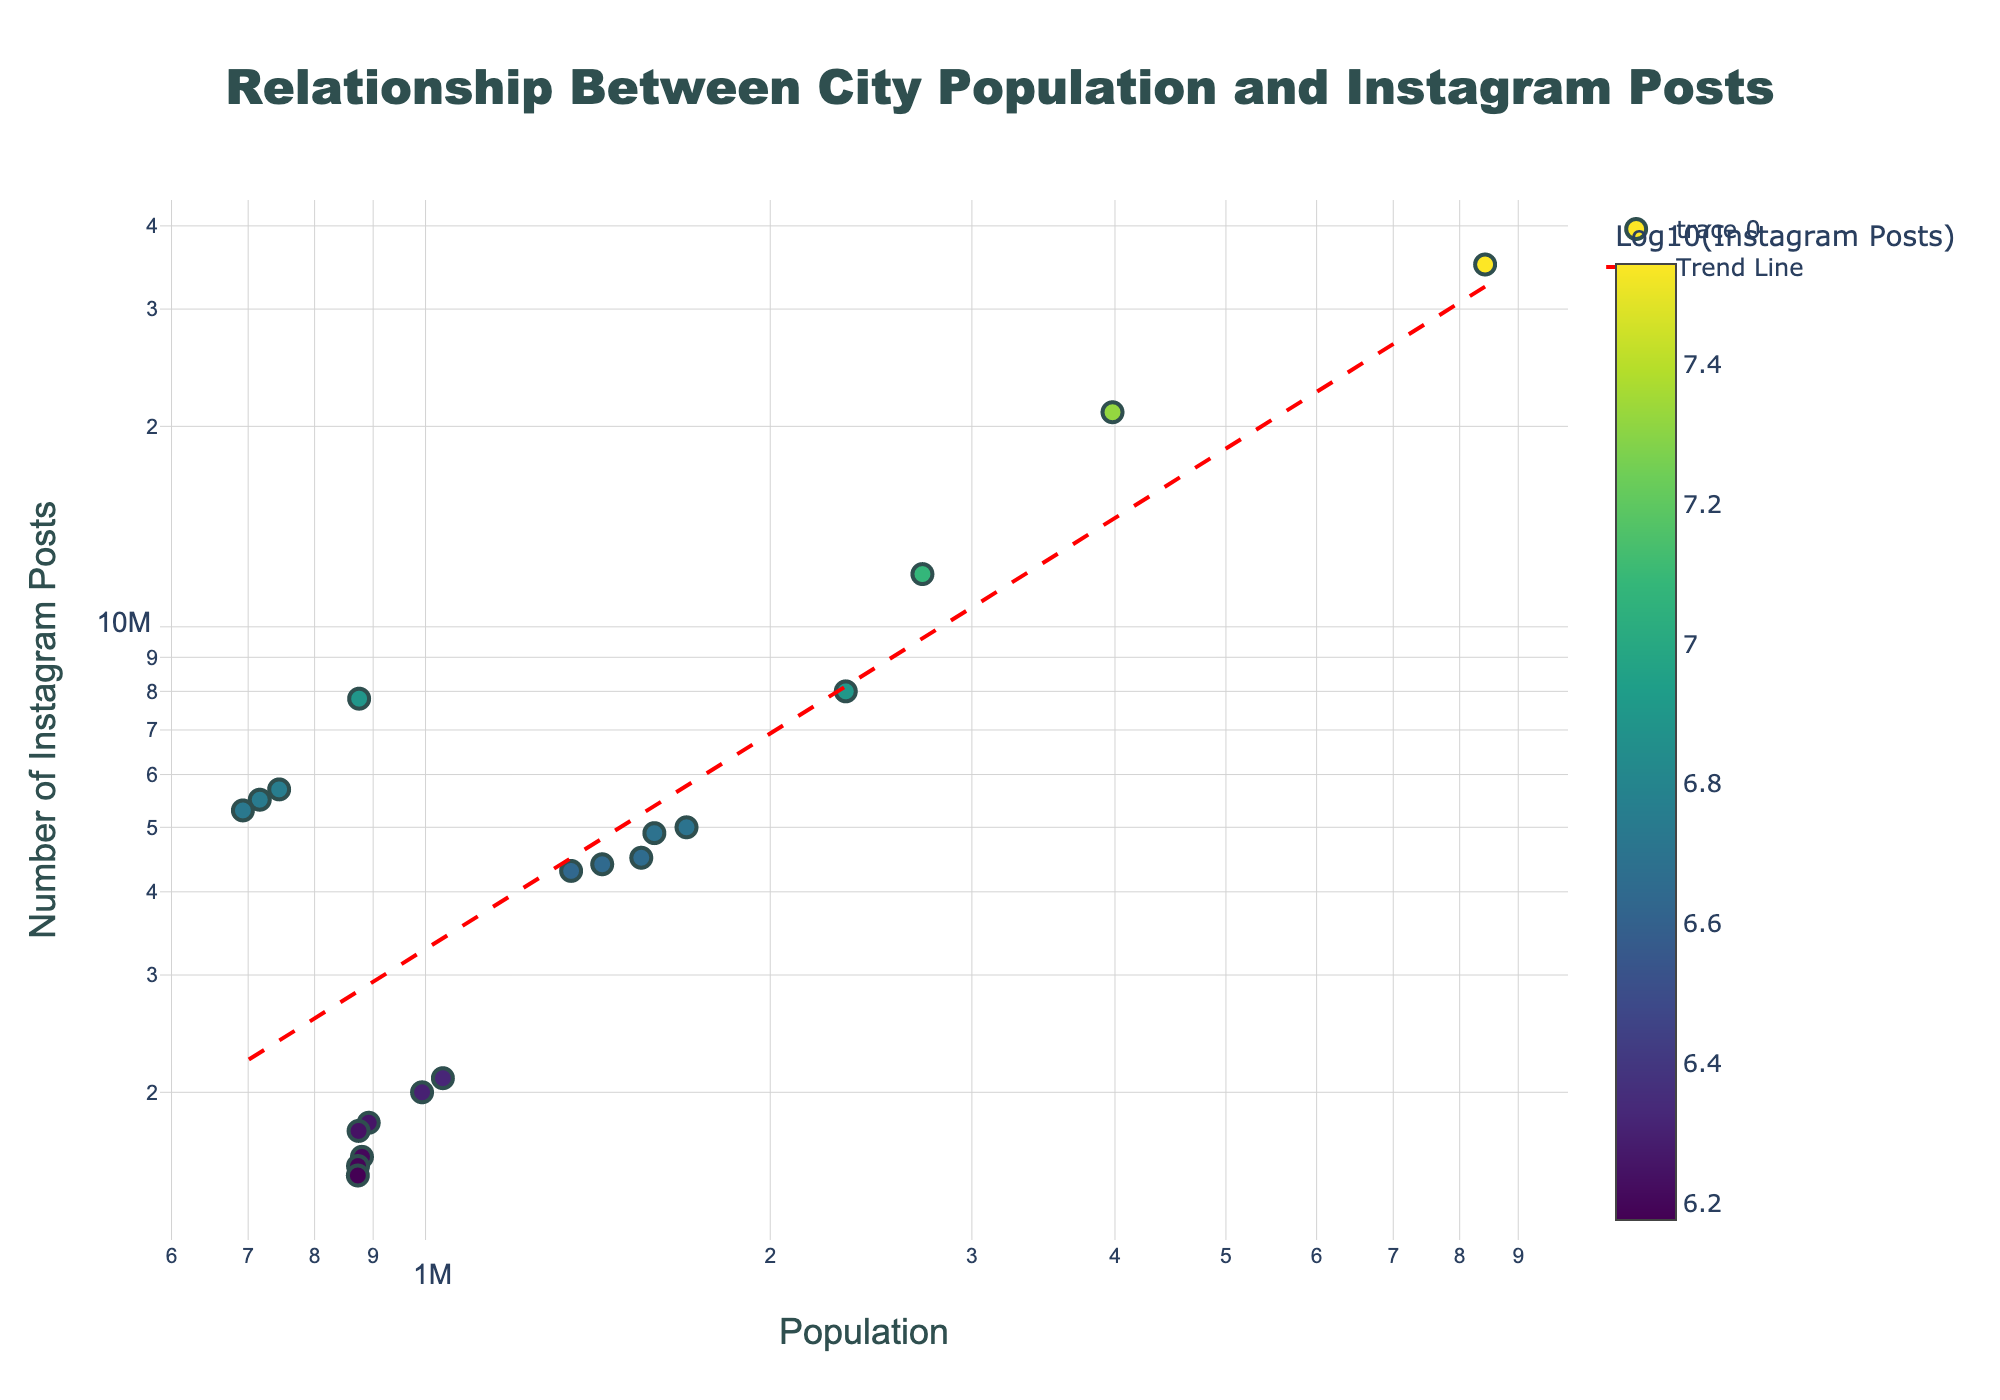What is the title of the plot? The title of the plot is displayed prominently at the top. It reads "Relationship Between City Population and Instagram Posts."
Answer: Relationship Between City Population and Instagram Posts How are the axes labeled in the plot? The x-axis is labeled "Population" and the y-axis is labeled "Number of Instagram Posts." Both axes use a logarithmic scale.
Answer: Population (x-axis), Number of Instagram Posts (y-axis) What do the colors of the markers represent? The colors of the markers correspond to the logarithm (base 10) of the number of Instagram posts. A color scale titled "Log10(Instagram Posts)" is provided in the figure for reference.
Answer: Logarithm of Instagram Posts Which city has the highest number of Instagram posts and how many posts does it have? To determine this, look for the highest point on the y-axis. New York has the highest number of Instagram posts, with 35,000,000.
Answer: New York, 35,000,000 Which city has a population closest to 1,000,000 and how many Instagram posts does it have? Identify the marker closest to 1,000,000 on the x-axis. It is San Jose with 2,100,000 Instagram posts.
Answer: San Jose, 2,100,000 Between Houston and Phoenix, which city has more Instagram posts, and by how much? Locate both cities on the plot and compare their y-axis values. Houston has 8,000,000 Instagram posts, and Phoenix has 5,000,000, so Houston has 3,000,000 more posts than Phoenix.
Answer: Houston, 3,000,000 What is the approximate trend line equation found in the plot? The trend line equation is based on the log-log regression provided in the plot. Its exact form is not shown in the visual, but it suggests a linear relationship in the log-log scale.
Answer: Linear in log-log scale Do larger cities tend to have more Instagram posts? Generally, observe the overall direction of the trend line. Since larger populations align with higher numbers of Instagram posts, this indicates that, on average, larger cities tend to have more Instagram posts.
Answer: Yes, larger cities tend to have more Instagram posts Which city has a higher number of Instagram posts, San Francisco or Philadelphia? Compare the y-axis values for both cities. San Francisco has 7,800,000 Instagram posts, and Philadelphia has 4,900,000 Instagram posts.
Answer: San Francisco Is there any outlier with a significant number of Instagram posts compared to its population size? Look for markers that deviate significantly from the trend line. San Francisco stands out as an outlier with a higher number of Instagram posts (7,800,000) relative to its population size (874,961).
Answer: San Francisco 